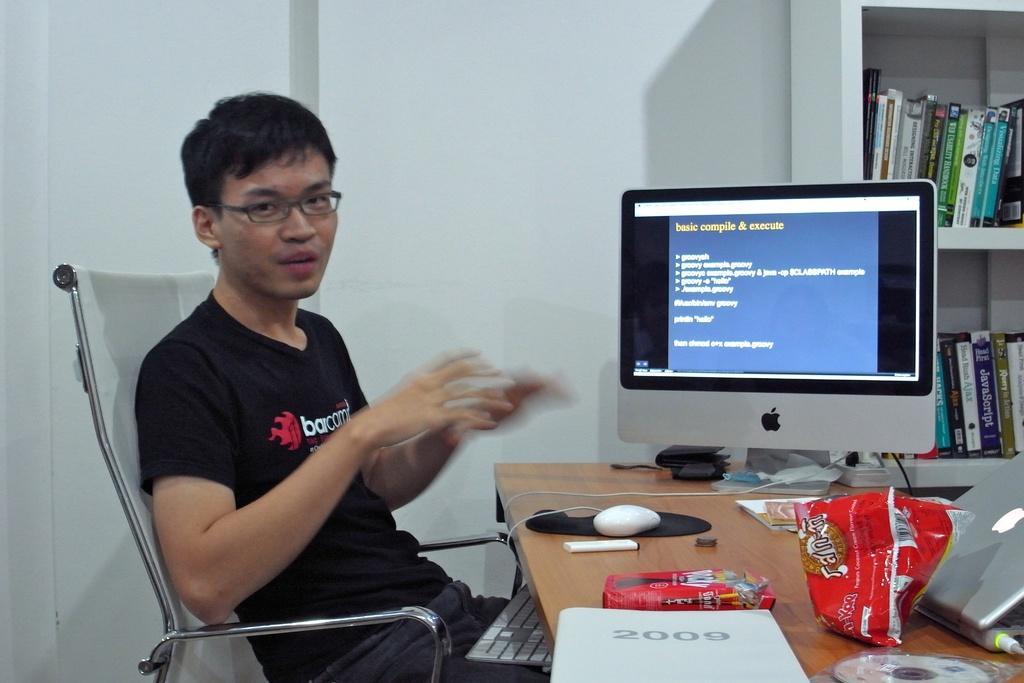Please provide a concise description of this image. This is an image clicked inside the room. Here I can see a man wearing t-shirt and sitting on the chair in front of the table. On the table I can see a monitor, laptop and few objects. In the background there is a wall. Beside that I can see a rack having some books in it. 